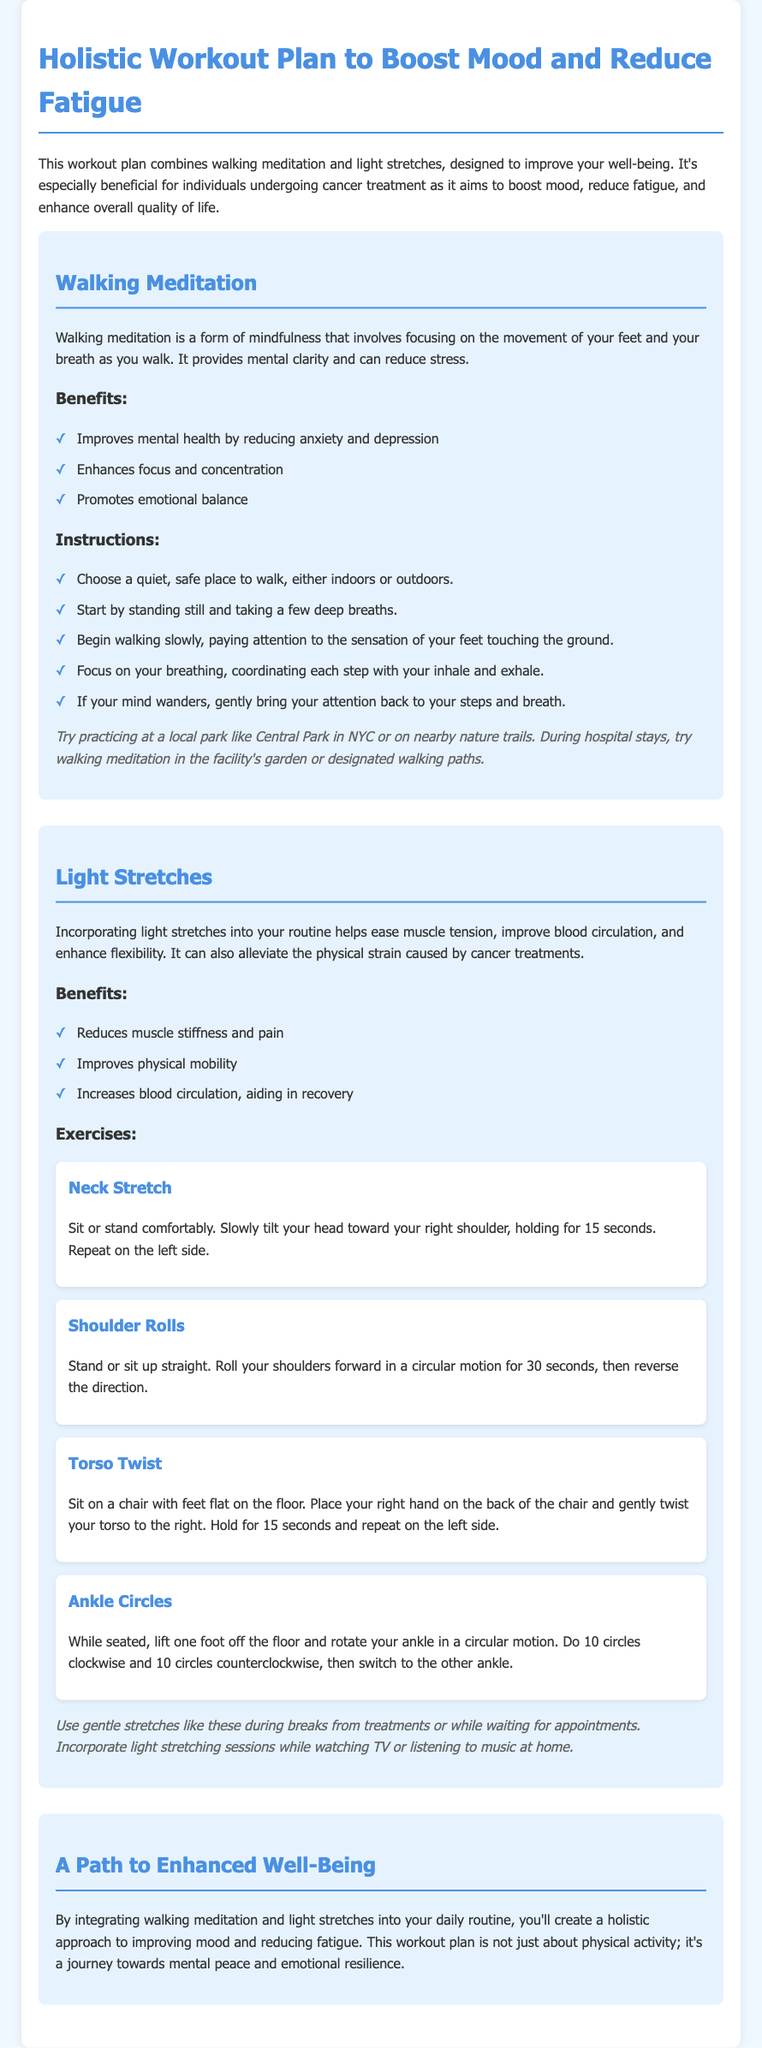What is the main goal of the workout plan? The goal is to improve well-being for individuals undergoing cancer treatment by boosting mood and reducing fatigue.
Answer: Boost mood and reduce fatigue What are the benefits of walking meditation? The benefits include improving mental health, enhancing focus, and promoting emotional balance.
Answer: Improves mental health, enhances focus, promotes emotional balance What should you start with before beginning walking meditation? You should start by standing still and taking a few deep breaths.
Answer: Taking a few deep breaths How long should you hold the neck stretch? You should hold the neck stretch for 15 seconds.
Answer: 15 seconds How many circles do you do for each ankle in the Ankle Circles exercise? You do 10 circles clockwise and 10 circles counterclockwise.
Answer: 10 circles What are the light stretches intended to alleviate? The light stretches are intended to alleviate physical strain caused by cancer treatments.
Answer: Physical strain from cancer treatments Where is a suggested place to practice walking meditation? A suggested place is at a local park like Central Park in NYC.
Answer: Central Park in NYC What type of approach does the workout plan promote? The workout plan promotes a holistic approach to improving mood and reducing fatigue.
Answer: Holistic approach 